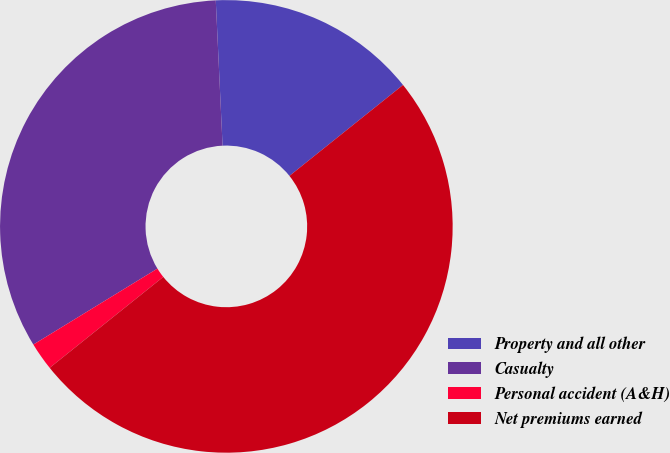Convert chart. <chart><loc_0><loc_0><loc_500><loc_500><pie_chart><fcel>Property and all other<fcel>Casualty<fcel>Personal accident (A&H)<fcel>Net premiums earned<nl><fcel>15.0%<fcel>33.0%<fcel>2.0%<fcel>50.0%<nl></chart> 